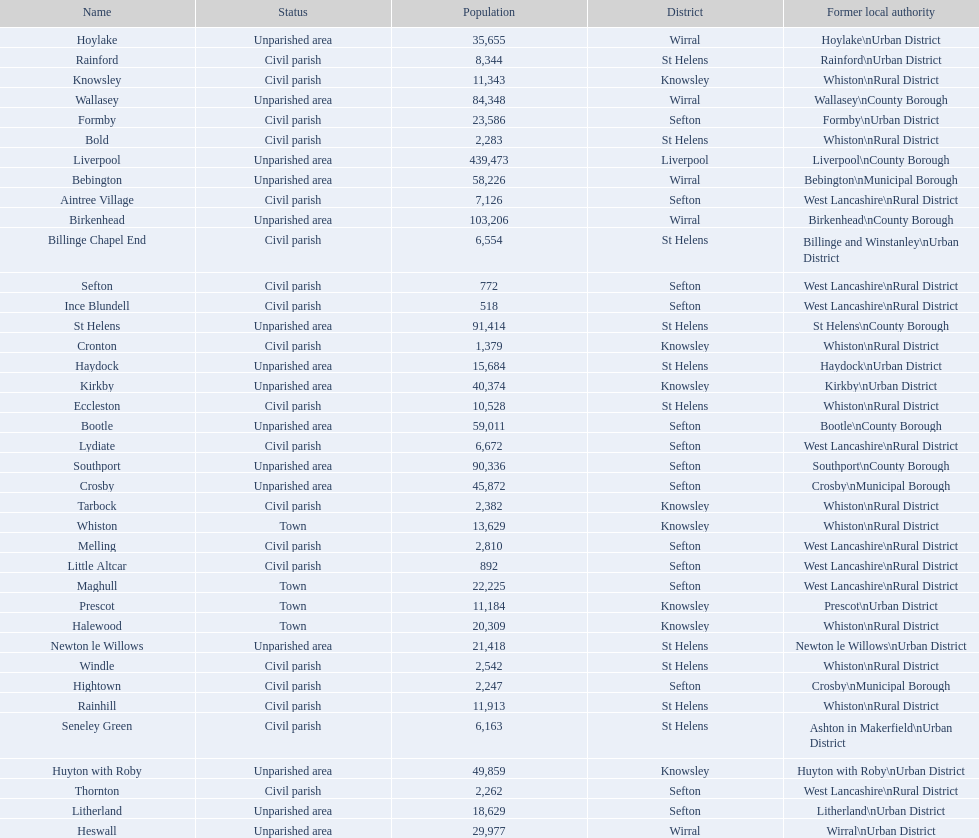How many people live in the bold civil parish? 2,283. 